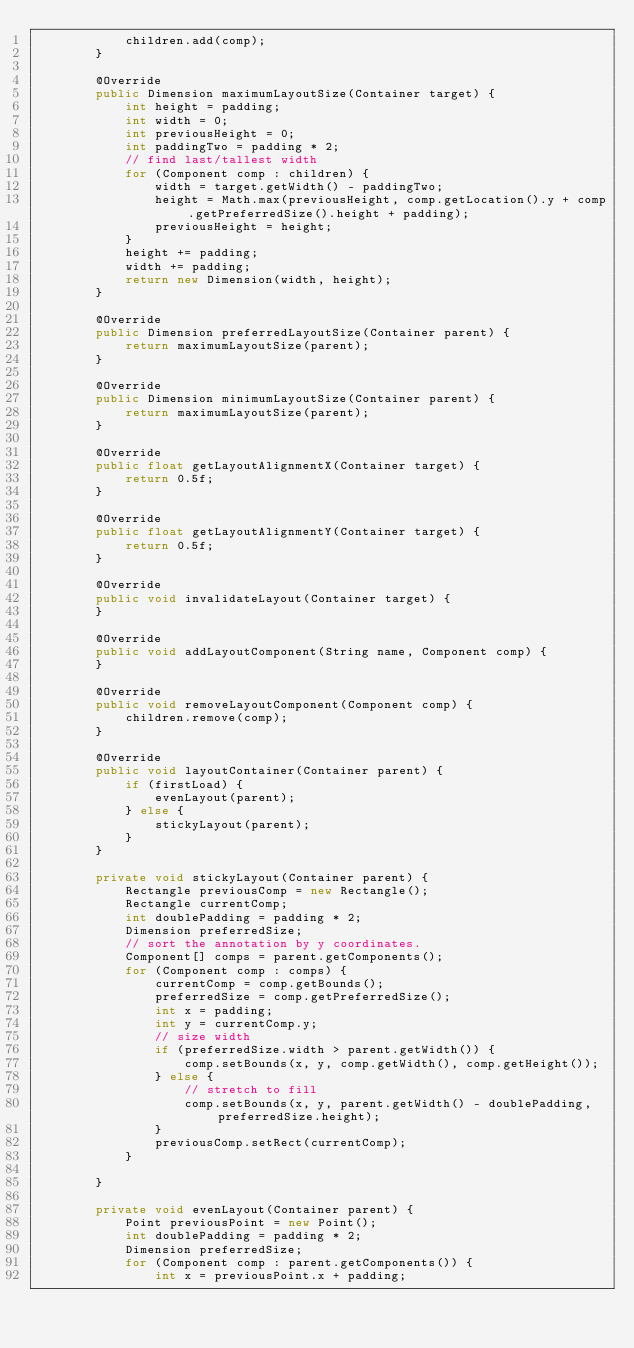<code> <loc_0><loc_0><loc_500><loc_500><_Java_>            children.add(comp);
        }

        @Override
        public Dimension maximumLayoutSize(Container target) {
            int height = padding;
            int width = 0;
            int previousHeight = 0;
            int paddingTwo = padding * 2;
            // find last/tallest width
            for (Component comp : children) {
                width = target.getWidth() - paddingTwo;
                height = Math.max(previousHeight, comp.getLocation().y + comp.getPreferredSize().height + padding);
                previousHeight = height;
            }
            height += padding;
            width += padding;
            return new Dimension(width, height);
        }

        @Override
        public Dimension preferredLayoutSize(Container parent) {
            return maximumLayoutSize(parent);
        }

        @Override
        public Dimension minimumLayoutSize(Container parent) {
            return maximumLayoutSize(parent);
        }

        @Override
        public float getLayoutAlignmentX(Container target) {
            return 0.5f;
        }

        @Override
        public float getLayoutAlignmentY(Container target) {
            return 0.5f;
        }

        @Override
        public void invalidateLayout(Container target) {
        }

        @Override
        public void addLayoutComponent(String name, Component comp) {
        }

        @Override
        public void removeLayoutComponent(Component comp) {
            children.remove(comp);
        }

        @Override
        public void layoutContainer(Container parent) {
            if (firstLoad) {
                evenLayout(parent);
            } else {
                stickyLayout(parent);
            }
        }

        private void stickyLayout(Container parent) {
            Rectangle previousComp = new Rectangle();
            Rectangle currentComp;
            int doublePadding = padding * 2;
            Dimension preferredSize;
            // sort the annotation by y coordinates.
            Component[] comps = parent.getComponents();
            for (Component comp : comps) {
                currentComp = comp.getBounds();
                preferredSize = comp.getPreferredSize();
                int x = padding;
                int y = currentComp.y;
                // size width
                if (preferredSize.width > parent.getWidth()) {
                    comp.setBounds(x, y, comp.getWidth(), comp.getHeight());
                } else {
                    // stretch to fill
                    comp.setBounds(x, y, parent.getWidth() - doublePadding, preferredSize.height);
                }
                previousComp.setRect(currentComp);
            }

        }

        private void evenLayout(Container parent) {
            Point previousPoint = new Point();
            int doublePadding = padding * 2;
            Dimension preferredSize;
            for (Component comp : parent.getComponents()) {
                int x = previousPoint.x + padding;</code> 